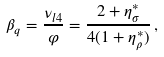<formula> <loc_0><loc_0><loc_500><loc_500>\beta _ { q } = \frac { \nu _ { l 4 } } { \varphi } = \frac { 2 + \eta _ { \sigma } ^ { * } } { 4 ( 1 + \eta _ { \rho } ^ { * } ) } \, ,</formula> 